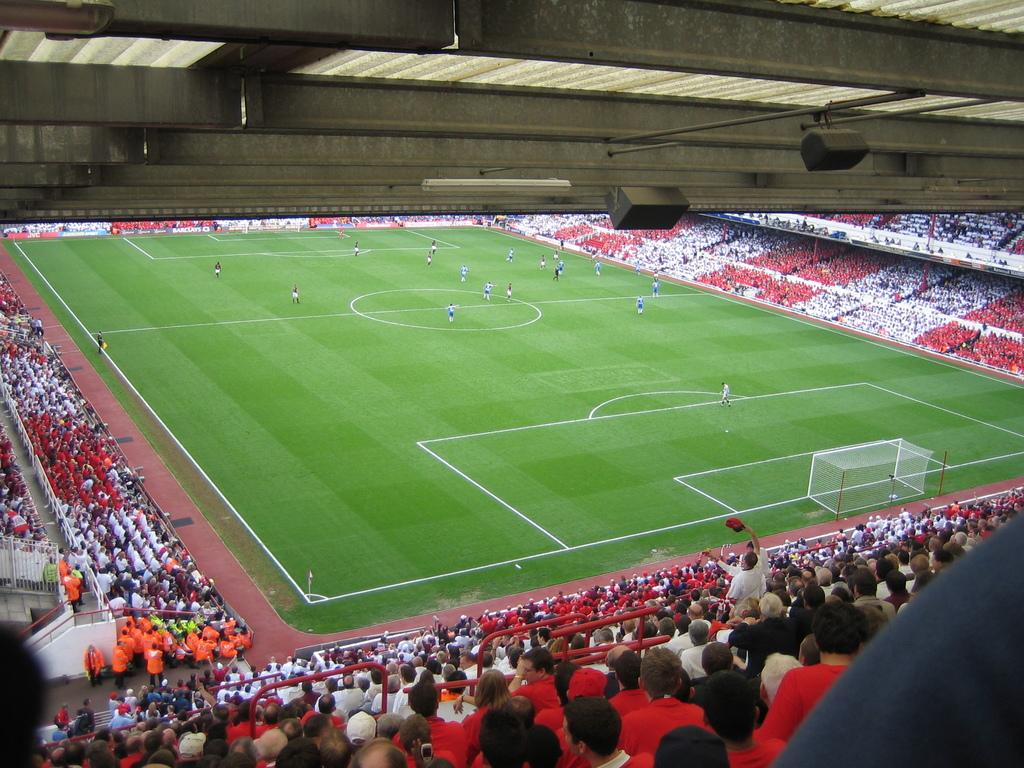What type of equipment is present in the image? There are speakers and lights in the image. What type of structure is visible in the image? There is a roof and ground visible in the image. Who or what is present in the image? There are people in the image. What type of architectural feature can be seen in the image? There are railings and mesh in the image. Can you describe any unspecified objects in the image? There are unspecified objects in the image. Reasoning: Let's think step by step by step in order to produce the conversation. We start by identifying the main equipment and structures in the image, which are the speakers and lights, as well as the roof and ground. Then, we mention the presence of people and describe the architectural features, such as railings and mesh. Finally, we acknowledge the presence of unspecified objects, which are mentioned in the facts but not described in detail. Absurd Question/Answer: What type of instrument is being played by the achiever in the image? There is no instrument or achiever present in the image. What type of vase is visible on the table in the image? There is no vase present in the image. 